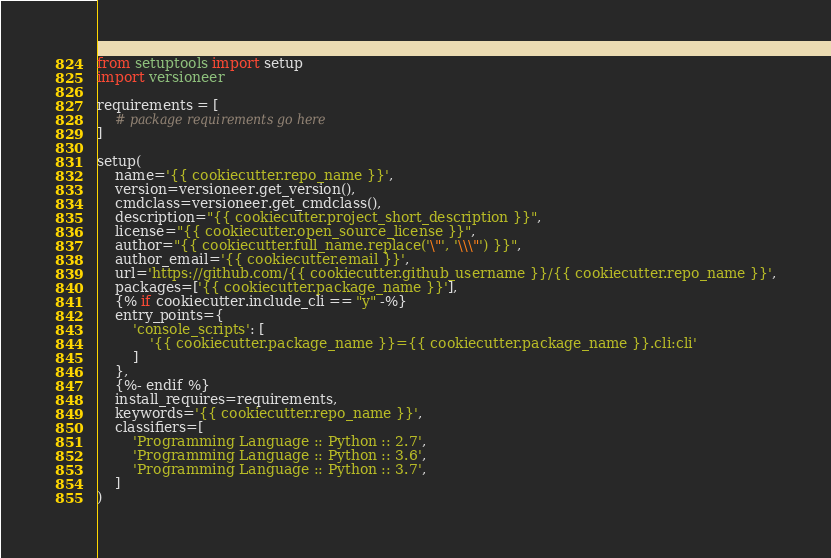Convert code to text. <code><loc_0><loc_0><loc_500><loc_500><_Python_>from setuptools import setup
import versioneer

requirements = [
    # package requirements go here
]

setup(
    name='{{ cookiecutter.repo_name }}',
    version=versioneer.get_version(),
    cmdclass=versioneer.get_cmdclass(),
    description="{{ cookiecutter.project_short_description }}",
    license="{{ cookiecutter.open_source_license }}",
    author="{{ cookiecutter.full_name.replace('\"', '\\\"') }}",
    author_email='{{ cookiecutter.email }}',
    url='https://github.com/{{ cookiecutter.github_username }}/{{ cookiecutter.repo_name }}',
    packages=['{{ cookiecutter.package_name }}'],
    {% if cookiecutter.include_cli == "y" -%}
    entry_points={
        'console_scripts': [
            '{{ cookiecutter.package_name }}={{ cookiecutter.package_name }}.cli:cli'
        ]
    },
    {%- endif %}
    install_requires=requirements,
    keywords='{{ cookiecutter.repo_name }}',
    classifiers=[
        'Programming Language :: Python :: 2.7',
        'Programming Language :: Python :: 3.6',
        'Programming Language :: Python :: 3.7',
    ]
)
</code> 